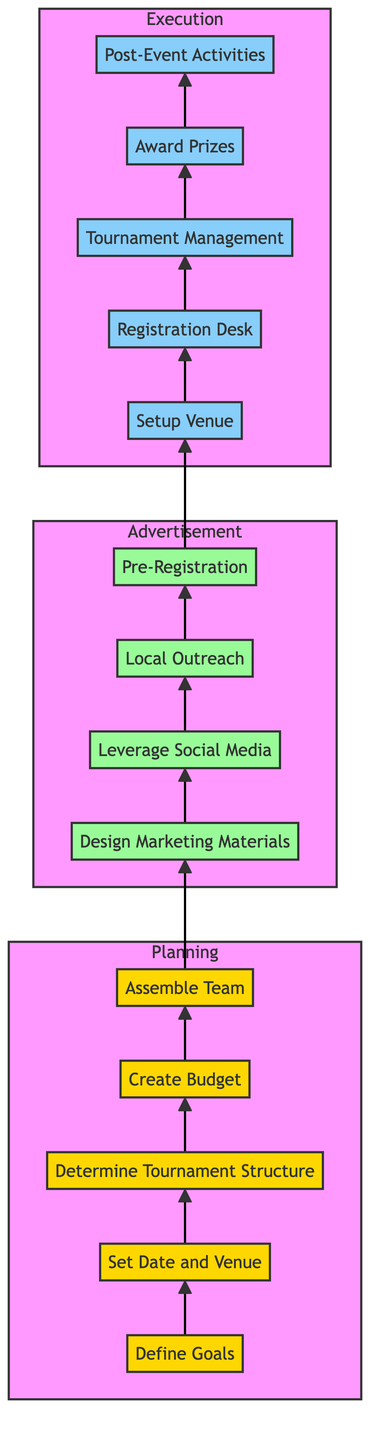What is the first step in Planning? The first step in the Planning stage is "Define Goals." This is identified clearly at the bottom of the Planning subsection of the diagram, marking the starting point of organizing the tournament.
Answer: Define Goals How many steps are there in the Execution phase? The Execution phase contains five steps, as shown in the diagram, listed sequentially from the Setup Venue to Post-Event Activities.
Answer: Five Which step follows "Leverage Social Media"? The step that follows "Leverage Social Media" is "Local Outreach." This is derived from tracing the flow of arrows in the Advertisement section of the diagram where each step is connected sequentially.
Answer: Local Outreach What is the last step in the tournament organization process? The last step in the entire process depicted in the diagram is "Post-Event Activities," which occurs at the top of the Execution stage, indicating it wraps up the tournament organization workflow.
Answer: Post-Event Activities What is the relationship between "Pre-Registration" and "Setup Venue"? The relationship is sequential; "Pre-Registration" precedes "Setup Venue" in the flow of the diagram. "Pre-Registration" is the final step in the Advertisement phase which connects to the first step in the Execution phase.
Answer: Sequential How many stages are depicted in the flow chart? There are three main stages depicted in the flow chart: Planning, Advertisement, and Execution. Each stage has its own set of steps to follow in organizing the community poker tournament.
Answer: Three What step immediately follows "Assemble Team"? The step that immediately follows "Assemble Team" is "Design Marketing Materials." This can be determined by tracing the flow from the end of the Planning stage to the beginning of the Advertisement stage in the diagram.
Answer: Design Marketing Materials Which stage involves financial considerations? The stage that involves financial considerations is Planning, particularly in the step "Create Budget," where anticipated costs and budgets are outlined to manage expenses for the tournament.
Answer: Planning 